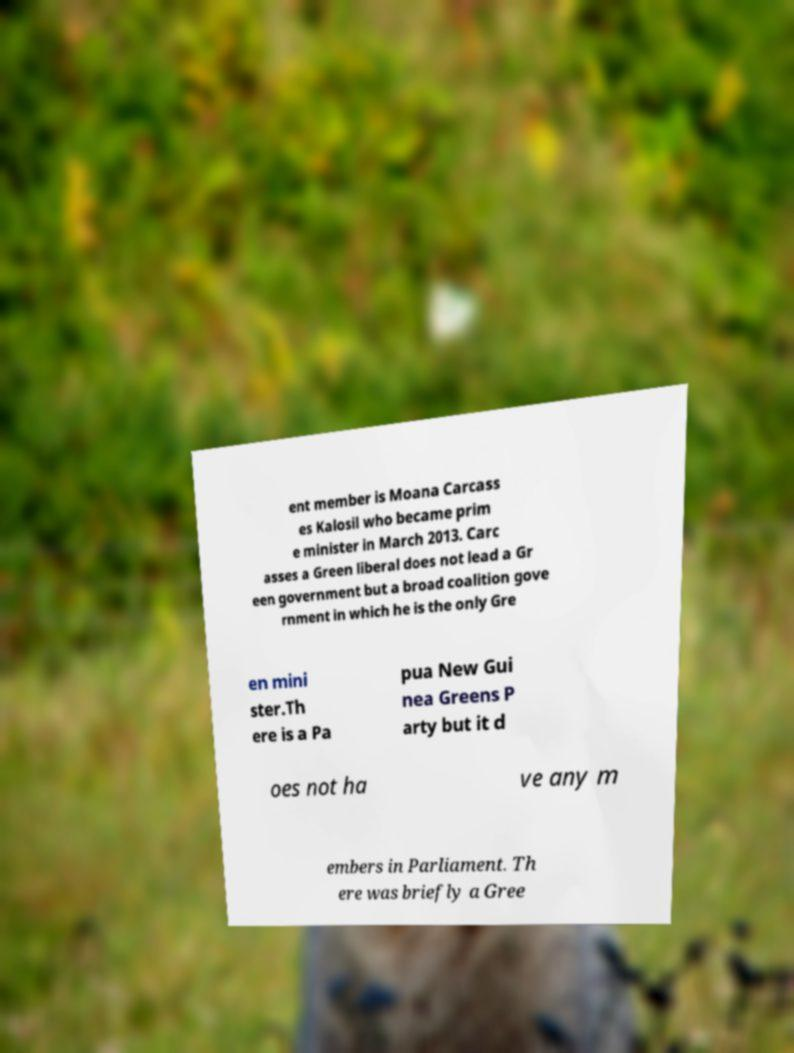Can you accurately transcribe the text from the provided image for me? ent member is Moana Carcass es Kalosil who became prim e minister in March 2013. Carc asses a Green liberal does not lead a Gr een government but a broad coalition gove rnment in which he is the only Gre en mini ster.Th ere is a Pa pua New Gui nea Greens P arty but it d oes not ha ve any m embers in Parliament. Th ere was briefly a Gree 